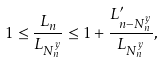<formula> <loc_0><loc_0><loc_500><loc_500>1 \leq \frac { L _ { n } } { L _ { N _ { n } ^ { y } } } \leq 1 + \frac { L ^ { \prime } _ { n - N _ { n } ^ { y } } } { L _ { N _ { n } ^ { y } } } ,</formula> 